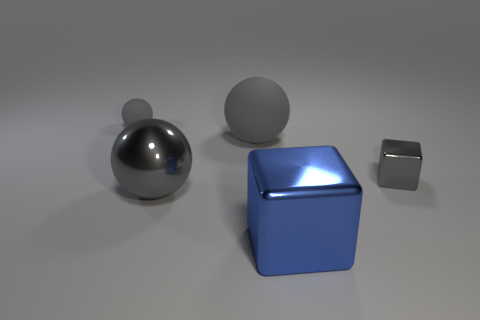Subtract all gray balls. How many were subtracted if there are1gray balls left? 2 Add 1 large objects. How many objects exist? 6 Subtract all large gray balls. How many balls are left? 1 Subtract 1 spheres. How many spheres are left? 2 Subtract all balls. How many objects are left? 2 Subtract all brown balls. Subtract all gray cylinders. How many balls are left? 3 Add 5 tiny gray blocks. How many tiny gray blocks are left? 6 Add 3 big gray objects. How many big gray objects exist? 5 Subtract 0 cyan cubes. How many objects are left? 5 Subtract all big blue cylinders. Subtract all gray metal balls. How many objects are left? 4 